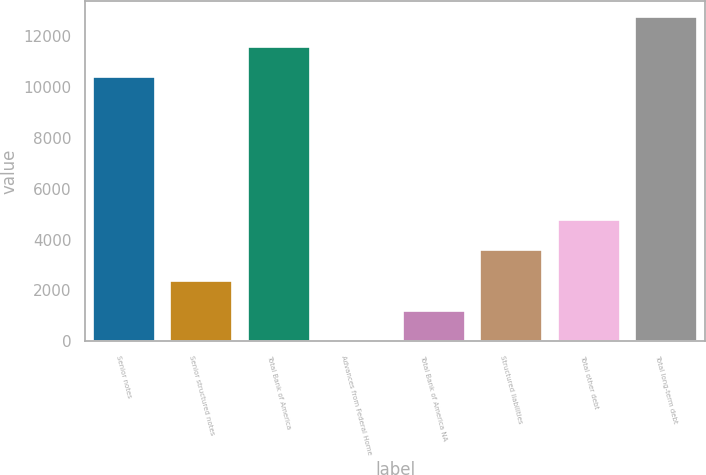<chart> <loc_0><loc_0><loc_500><loc_500><bar_chart><fcel>Senior notes<fcel>Senior structured notes<fcel>Total Bank of America<fcel>Advances from Federal Home<fcel>Total Bank of America NA<fcel>Structured liabilities<fcel>Total other debt<fcel>Total long-term debt<nl><fcel>10382<fcel>2381.2<fcel>11571.6<fcel>2<fcel>1191.6<fcel>3570.8<fcel>4760.4<fcel>12761.2<nl></chart> 